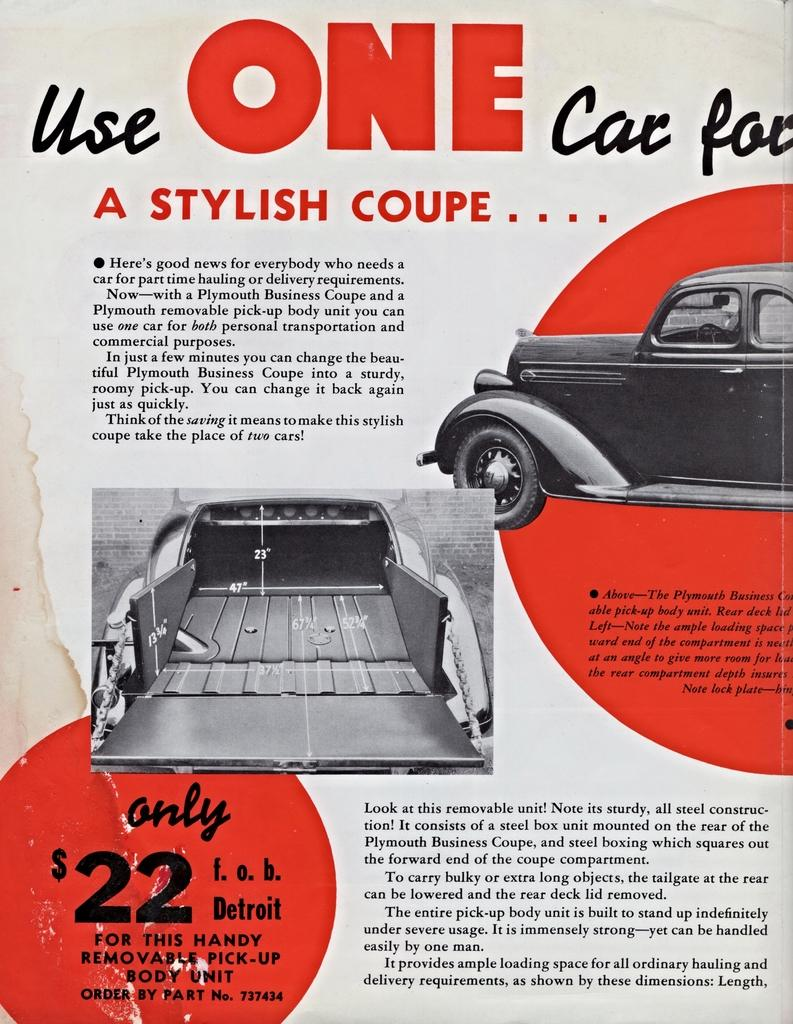What is present in the image that contains written information? There is a paper in the image that contains text. What else can be seen on the paper besides the text? The paper also contains images of cars. How does the bird move around on the paper in the image? There is no bird present on the paper in the image. 